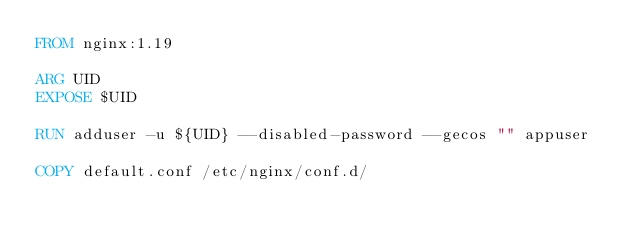Convert code to text. <code><loc_0><loc_0><loc_500><loc_500><_Dockerfile_>FROM nginx:1.19

ARG UID
EXPOSE $UID

RUN adduser -u ${UID} --disabled-password --gecos "" appuser

COPY default.conf /etc/nginx/conf.d/
</code> 